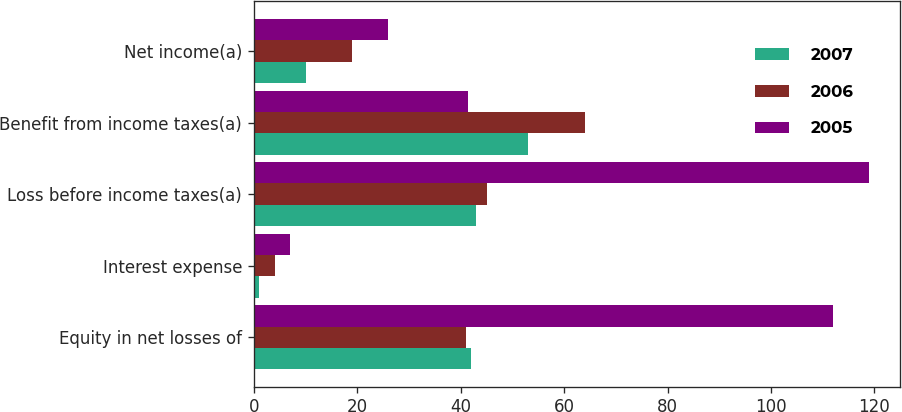Convert chart. <chart><loc_0><loc_0><loc_500><loc_500><stacked_bar_chart><ecel><fcel>Equity in net losses of<fcel>Interest expense<fcel>Loss before income taxes(a)<fcel>Benefit from income taxes(a)<fcel>Net income(a)<nl><fcel>2007<fcel>42<fcel>1<fcel>43<fcel>53<fcel>10<nl><fcel>2006<fcel>41<fcel>4<fcel>45<fcel>64<fcel>19<nl><fcel>2005<fcel>112<fcel>7<fcel>119<fcel>41.5<fcel>26<nl></chart> 